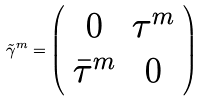<formula> <loc_0><loc_0><loc_500><loc_500>\tilde { \gamma } ^ { m } = \left ( \begin{array} { c c } 0 & \tau ^ { m } \\ \bar { \tau } ^ { m } & 0 \end{array} \right )</formula> 